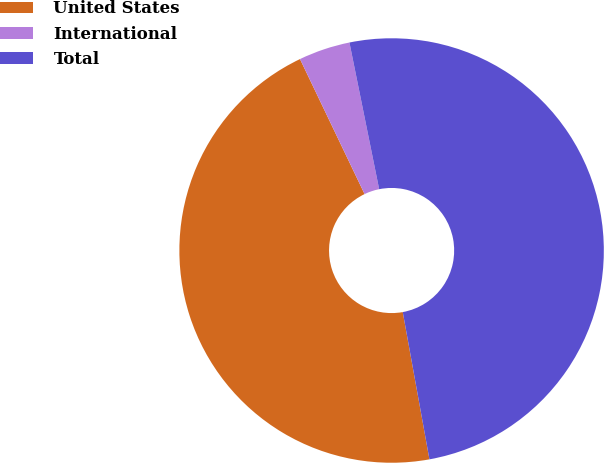<chart> <loc_0><loc_0><loc_500><loc_500><pie_chart><fcel>United States<fcel>International<fcel>Total<nl><fcel>45.75%<fcel>3.92%<fcel>50.33%<nl></chart> 